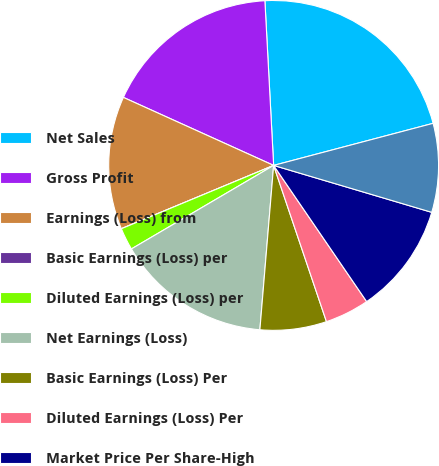<chart> <loc_0><loc_0><loc_500><loc_500><pie_chart><fcel>Net Sales<fcel>Gross Profit<fcel>Earnings (Loss) from<fcel>Basic Earnings (Loss) per<fcel>Diluted Earnings (Loss) per<fcel>Net Earnings (Loss)<fcel>Basic Earnings (Loss) Per<fcel>Diluted Earnings (Loss) Per<fcel>Market Price Per Share-High<fcel>Market Price Per Share-Low<nl><fcel>21.74%<fcel>17.39%<fcel>13.04%<fcel>0.0%<fcel>2.18%<fcel>15.22%<fcel>6.52%<fcel>4.35%<fcel>10.87%<fcel>8.7%<nl></chart> 